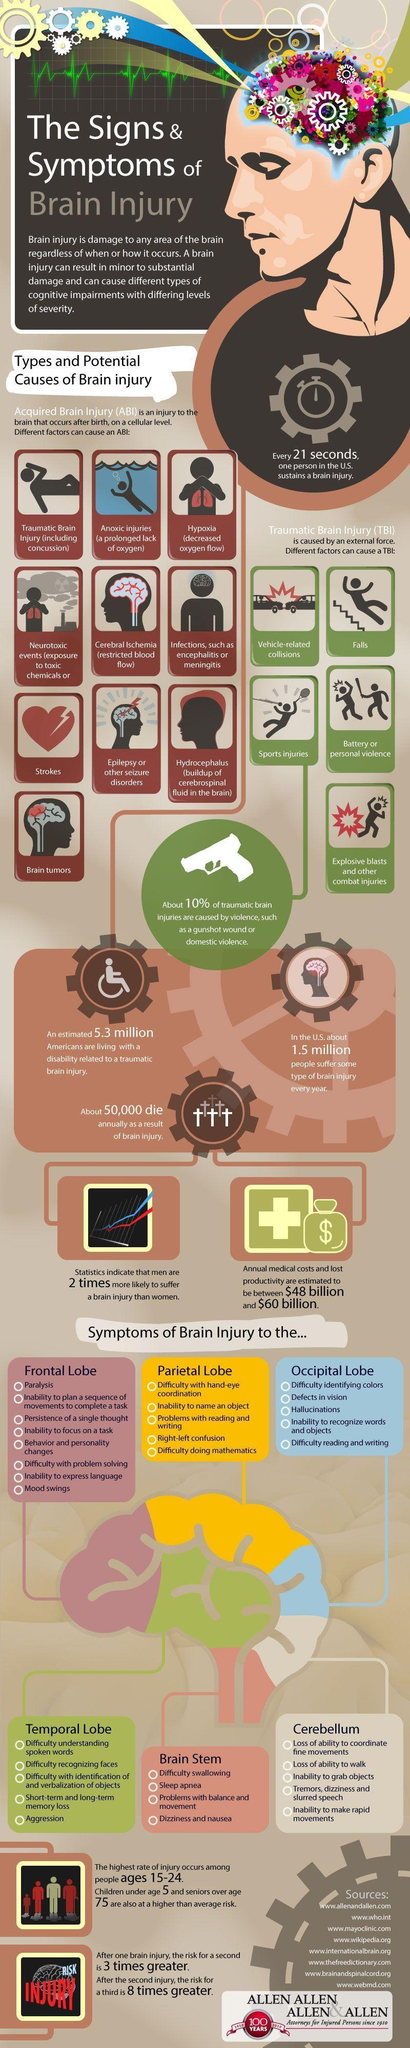How many parts are there for the Human Brain as given in the info graphic?
Answer the question with a short phrase. 6 How many factors can cause Acquired Brain Injury? 10 What is the color of the Temporal lobe in the info graphic pink, yellow, green or blue ? green How many symptoms of brain injury are listed under "Occipital Lobe"? 5 How many factors can cause Traumatic Brain Injury? 6 How many Americans are facing problems due to traumatic brain injury? 5.3 How many symptoms of brain injury are listed under "Parietal Lobe"? 5 